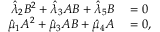<formula> <loc_0><loc_0><loc_500><loc_500>\begin{array} { r l } { \hat { \lambda } _ { 2 } B ^ { 2 } + \hat { \lambda } _ { 3 } A B + \hat { \lambda } _ { 5 } B } & = 0 } \\ { \hat { \mu } _ { 1 } A ^ { 2 } + \hat { \mu } _ { 3 } A B + \hat { \mu } _ { 4 } A } & = 0 , } \end{array}</formula> 